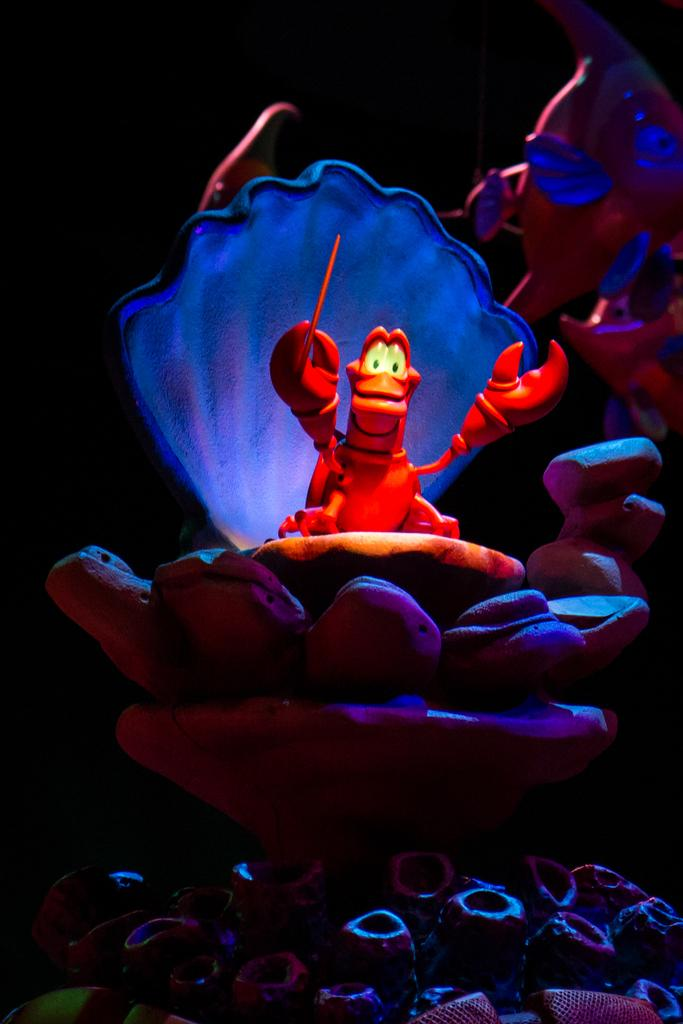What type of items can be seen in the image? There are toys in the image. Can you describe the background of the image? The background of the image is dark. What else is present in the image besides the toys? There are objects in the image. What type of art can be seen in the aftermath of the car accident in the image? There is no car accident or art present in the image; it features toys and objects with a dark background. 